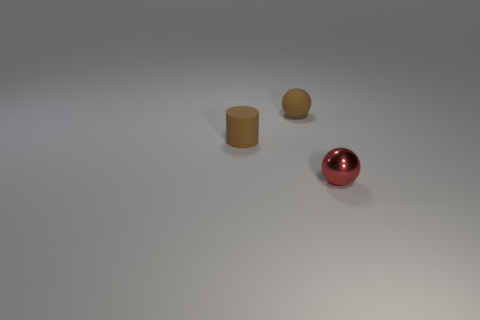Does the rubber cylinder have the same color as the shiny thing? No, the rubber cylinder does not share the same color as the shiny object. The rubber cylinder has a matte, beige-like color, whereas the shiny object, which appears to be a sphere, has a reflective, metallic red hue. 